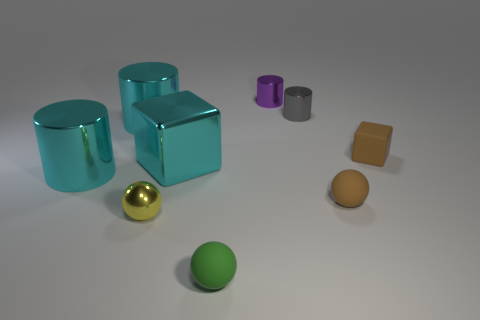Subtract all gray cylinders. Subtract all gray spheres. How many cylinders are left? 3 Add 1 cyan metal things. How many objects exist? 10 Subtract all cubes. How many objects are left? 7 Subtract all big yellow shiny spheres. Subtract all metal things. How many objects are left? 3 Add 1 yellow spheres. How many yellow spheres are left? 2 Add 4 shiny cubes. How many shiny cubes exist? 5 Subtract 1 yellow spheres. How many objects are left? 8 